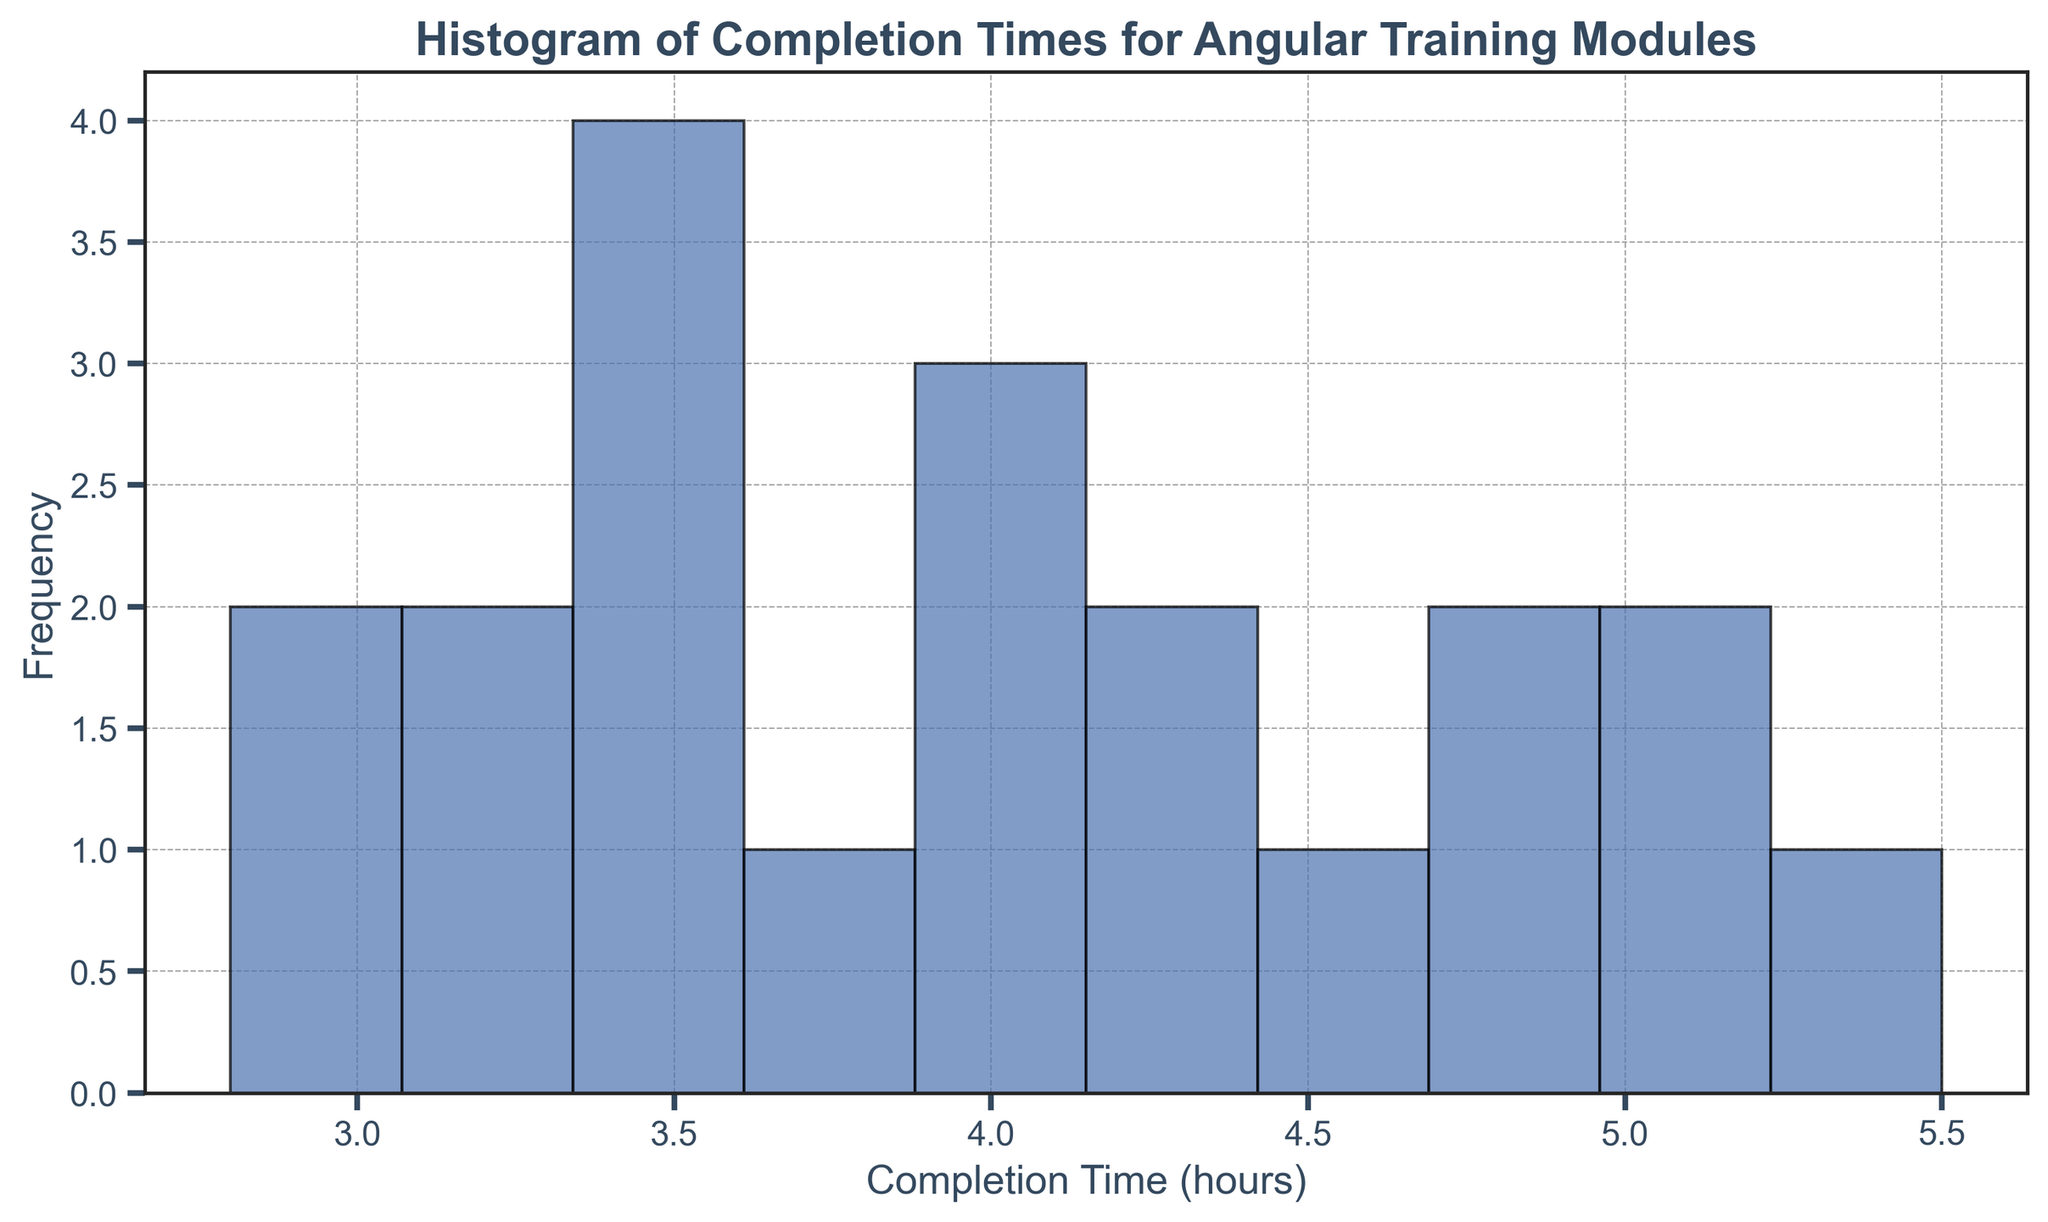What is the average completion time for the Angular training modules? To find the average completion time, add all the completion times together and divide by the number of modules. Sum of completion times: 3.5 + 4.0 + 3.8 + 4.2 + 4.5 + 5.0 + 5.2 + 4.8 + 5.5 + 4.7 + 3.9 + 3.6 + 4.3 + 2.8 + 3.2 + 4.0 + 3.4 + 3.6 + 2.9 + 3.3 = 81.2. There are 20 modules, so the average is 81.2 / 20.
Answer: 4.06 Which completion time range appears most frequently in the histogram? By observing the height of the bars in the histogram, the completion time range with the highest bar indicates the most frequent completion times. The highest bar is typically between 3.0 to 4.0 hours.
Answer: 3.0 to 4.0 hours How many modules have a completion time greater than 5 hours? Examine the histogram and count the number of modules that fall into bins greater than 5 hours. The bar heights show that there is 1 module in the range of 5.0 to 5.5 and 1 module in the range of 5.5 to 6.0.
Answer: 2 Is the completion time for most modules above or below 4 hours? By seeing the distribution of the bars, determine if the majority of the bars are higher on the side below or above the 4-hour mark. Most of the module completion times fall below 4 hours, as shown by the higher frequencies on that side of the histogram.
Answer: Below 4 hours What is the range of completion times for the Angular training modules? Identify the minimum and maximum completion times from the histogram to determine the range. The lowest completion time is around 2.8 hours, and the highest is about 5.5 hours.
Answer: 2.8 to 5.5 hours How does the frequency of modules with a completion time between 4 to 5 hours compare to those between 3 to 4 hours? By examining the heights of the bars in these ranges, compare their frequencies. The bar for the 3 to 4 hours range is taller, indicating more modules have completion times between 3 to 4 hours than those between 4 to 5 hours.
Answer: More frequent between 3 to 4 hours Are there any modules that have a completion time less than 3 hours? Observe the histogram to check for any bars representing completion times below 3 hours. There are indeed bars for completion times less than 3 hours.
Answer: Yes, there are modules What is the frequency of modules with a completion time exactly at 4 hours? Look at the bar that represents the completion time of exactly 4 hours and identify its height. There is one bar at the 4-hour mark, representing multiple modules.
Answer: The frequency is 2 Does any single completion time occur more frequently than others? Check if any bar stands out significantly taller than the others, indicating a frequently occurring completion time. No single completion time stands out as the most frequent, but the 3.0 to 4.0 hours range generally shows higher frequencies.
Answer: No single time, but 3.0 to 4.0 hours range is frequent 